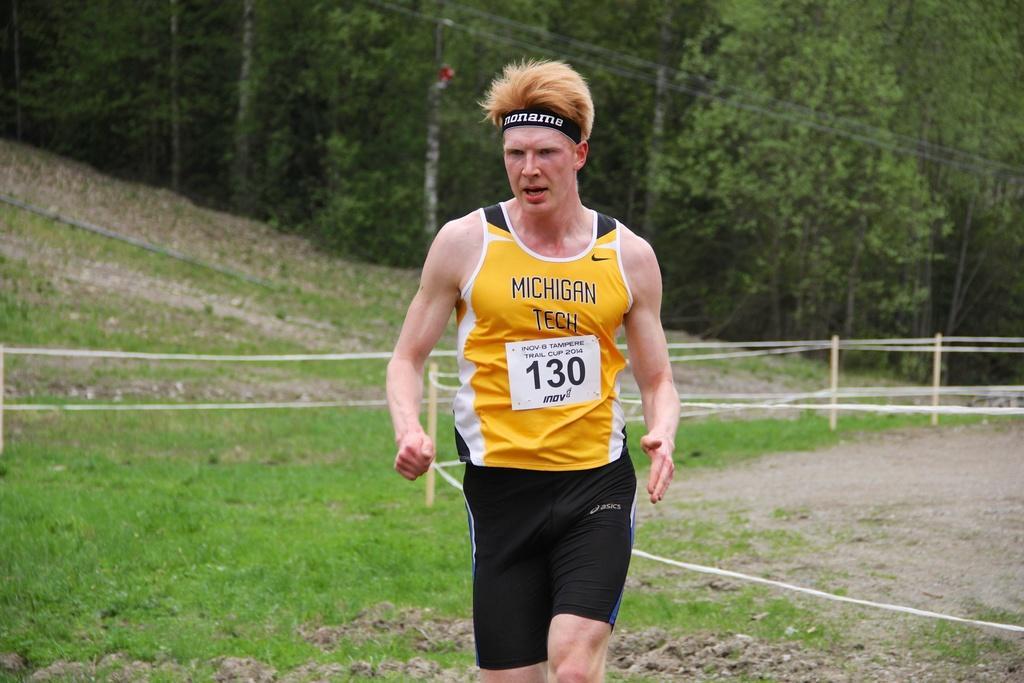Please provide a concise description of this image. In the picture we can see a man running on the grass surface area, he is wearing a yellow top and a band of the head and in the background we can see a grass surface and trees. 